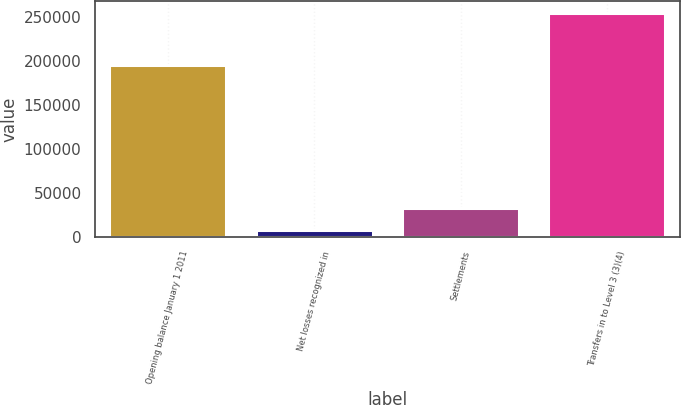Convert chart to OTSL. <chart><loc_0><loc_0><loc_500><loc_500><bar_chart><fcel>Opening balance January 1 2011<fcel>Net losses recognized in<fcel>Settlements<fcel>Transfers in to Level 3 (3)(4)<nl><fcel>195220<fcel>7898<fcel>32571.9<fcel>254637<nl></chart> 